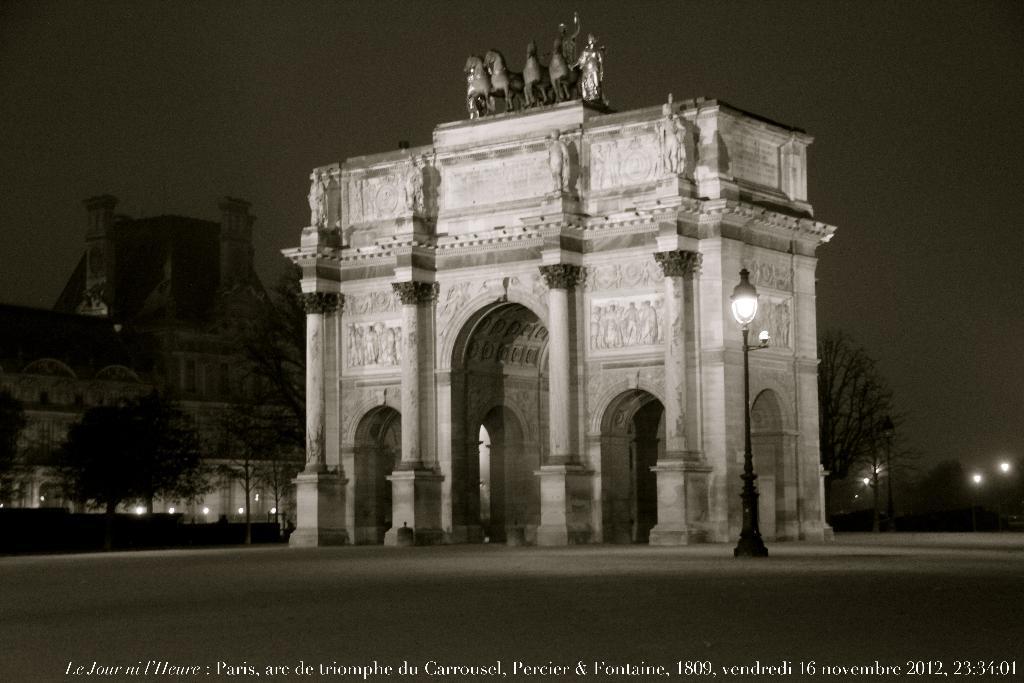Could you give a brief overview of what you see in this image? There is a watermark. In the background, there is a road, a light attached to the roof, there are statues on an architecture which is on the ground, there are trees, lights arranged, a building and there is a sky. 